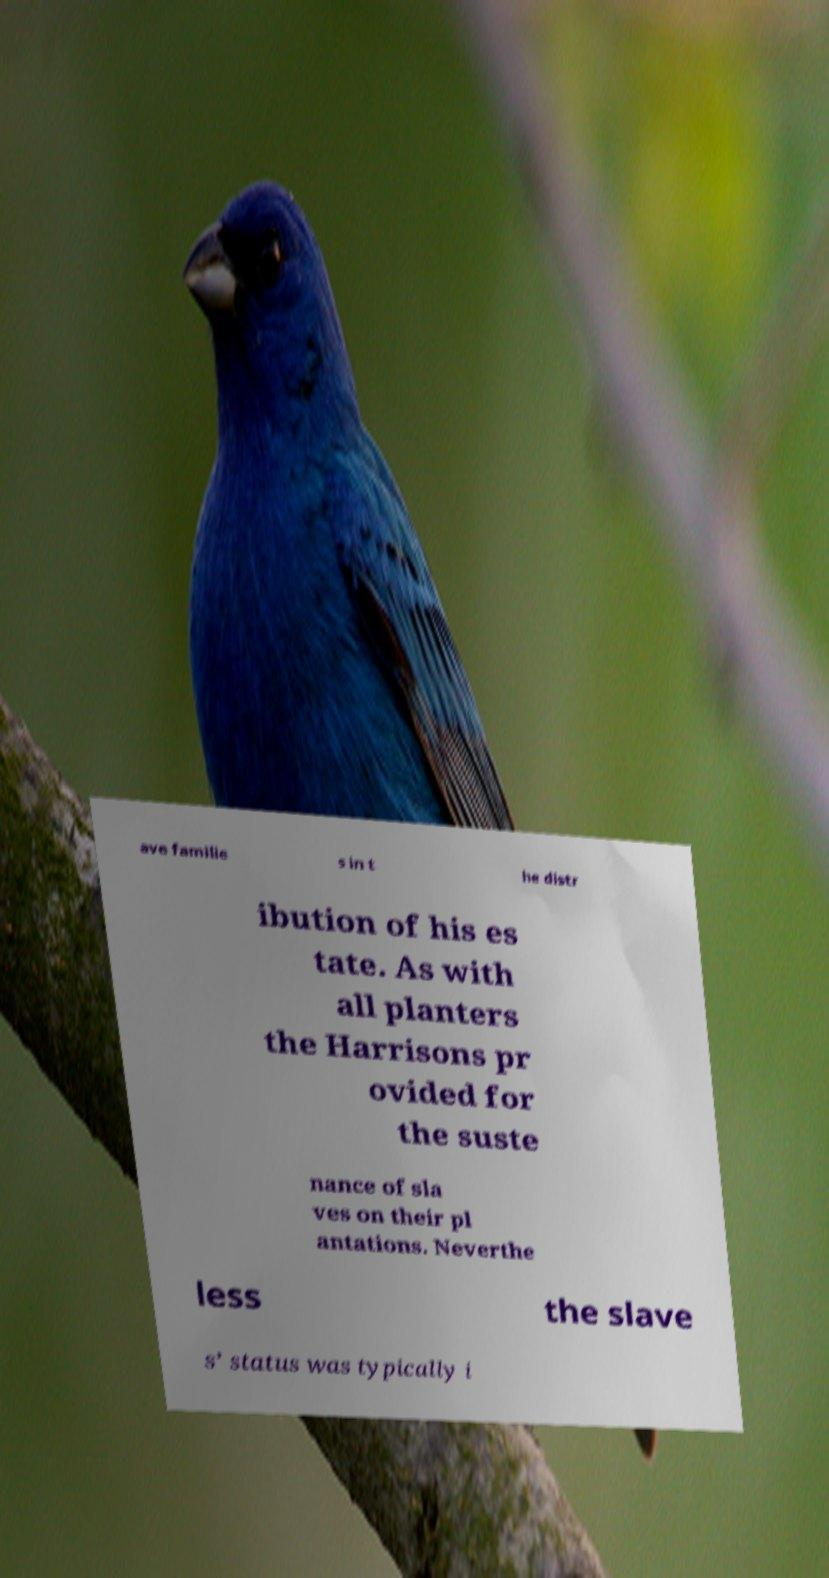For documentation purposes, I need the text within this image transcribed. Could you provide that? ave familie s in t he distr ibution of his es tate. As with all planters the Harrisons pr ovided for the suste nance of sla ves on their pl antations. Neverthe less the slave s’ status was typically i 